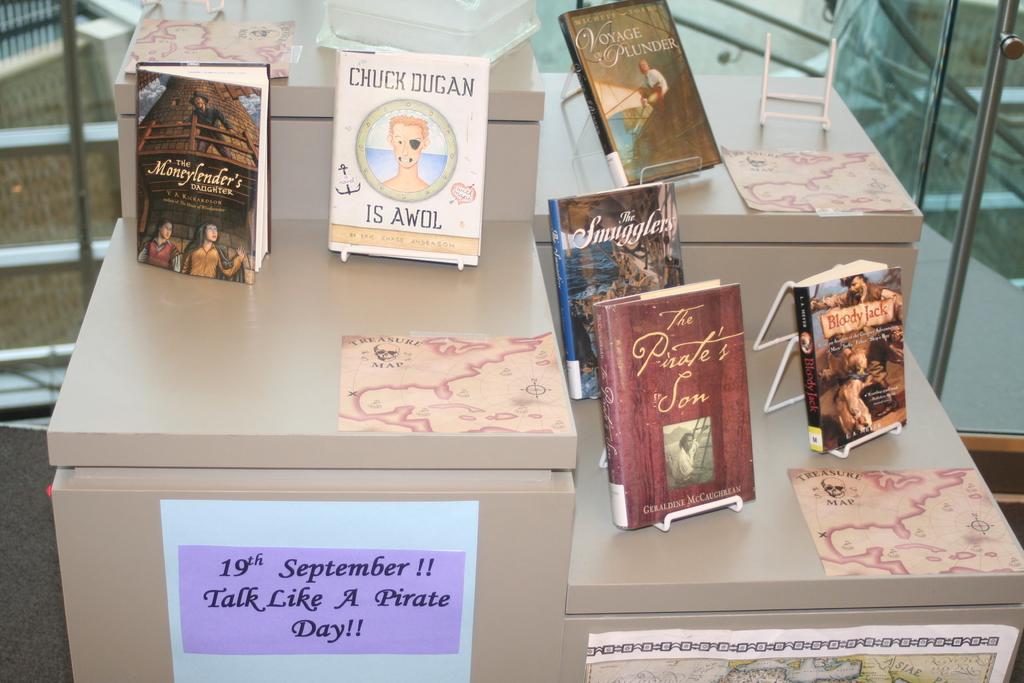What is the red book called?
Provide a succinct answer. The pirate's son. 